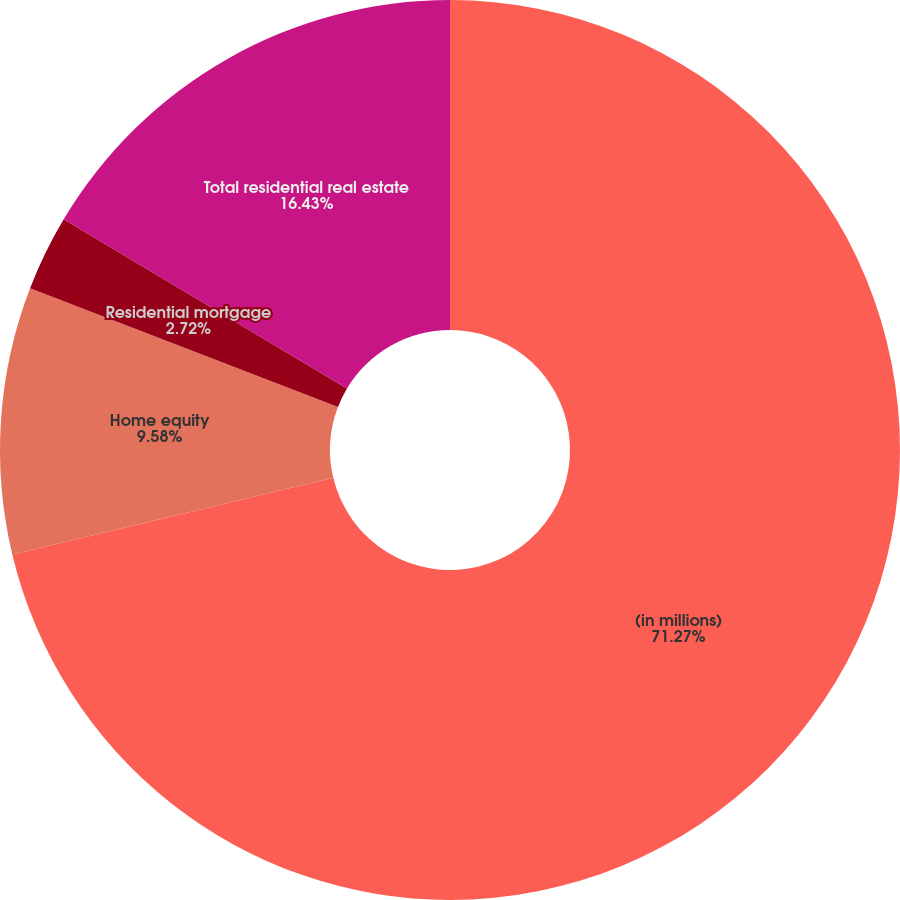Convert chart. <chart><loc_0><loc_0><loc_500><loc_500><pie_chart><fcel>(in millions)<fcel>Home equity<fcel>Residential mortgage<fcel>Total residential real estate<nl><fcel>71.27%<fcel>9.58%<fcel>2.72%<fcel>16.43%<nl></chart> 